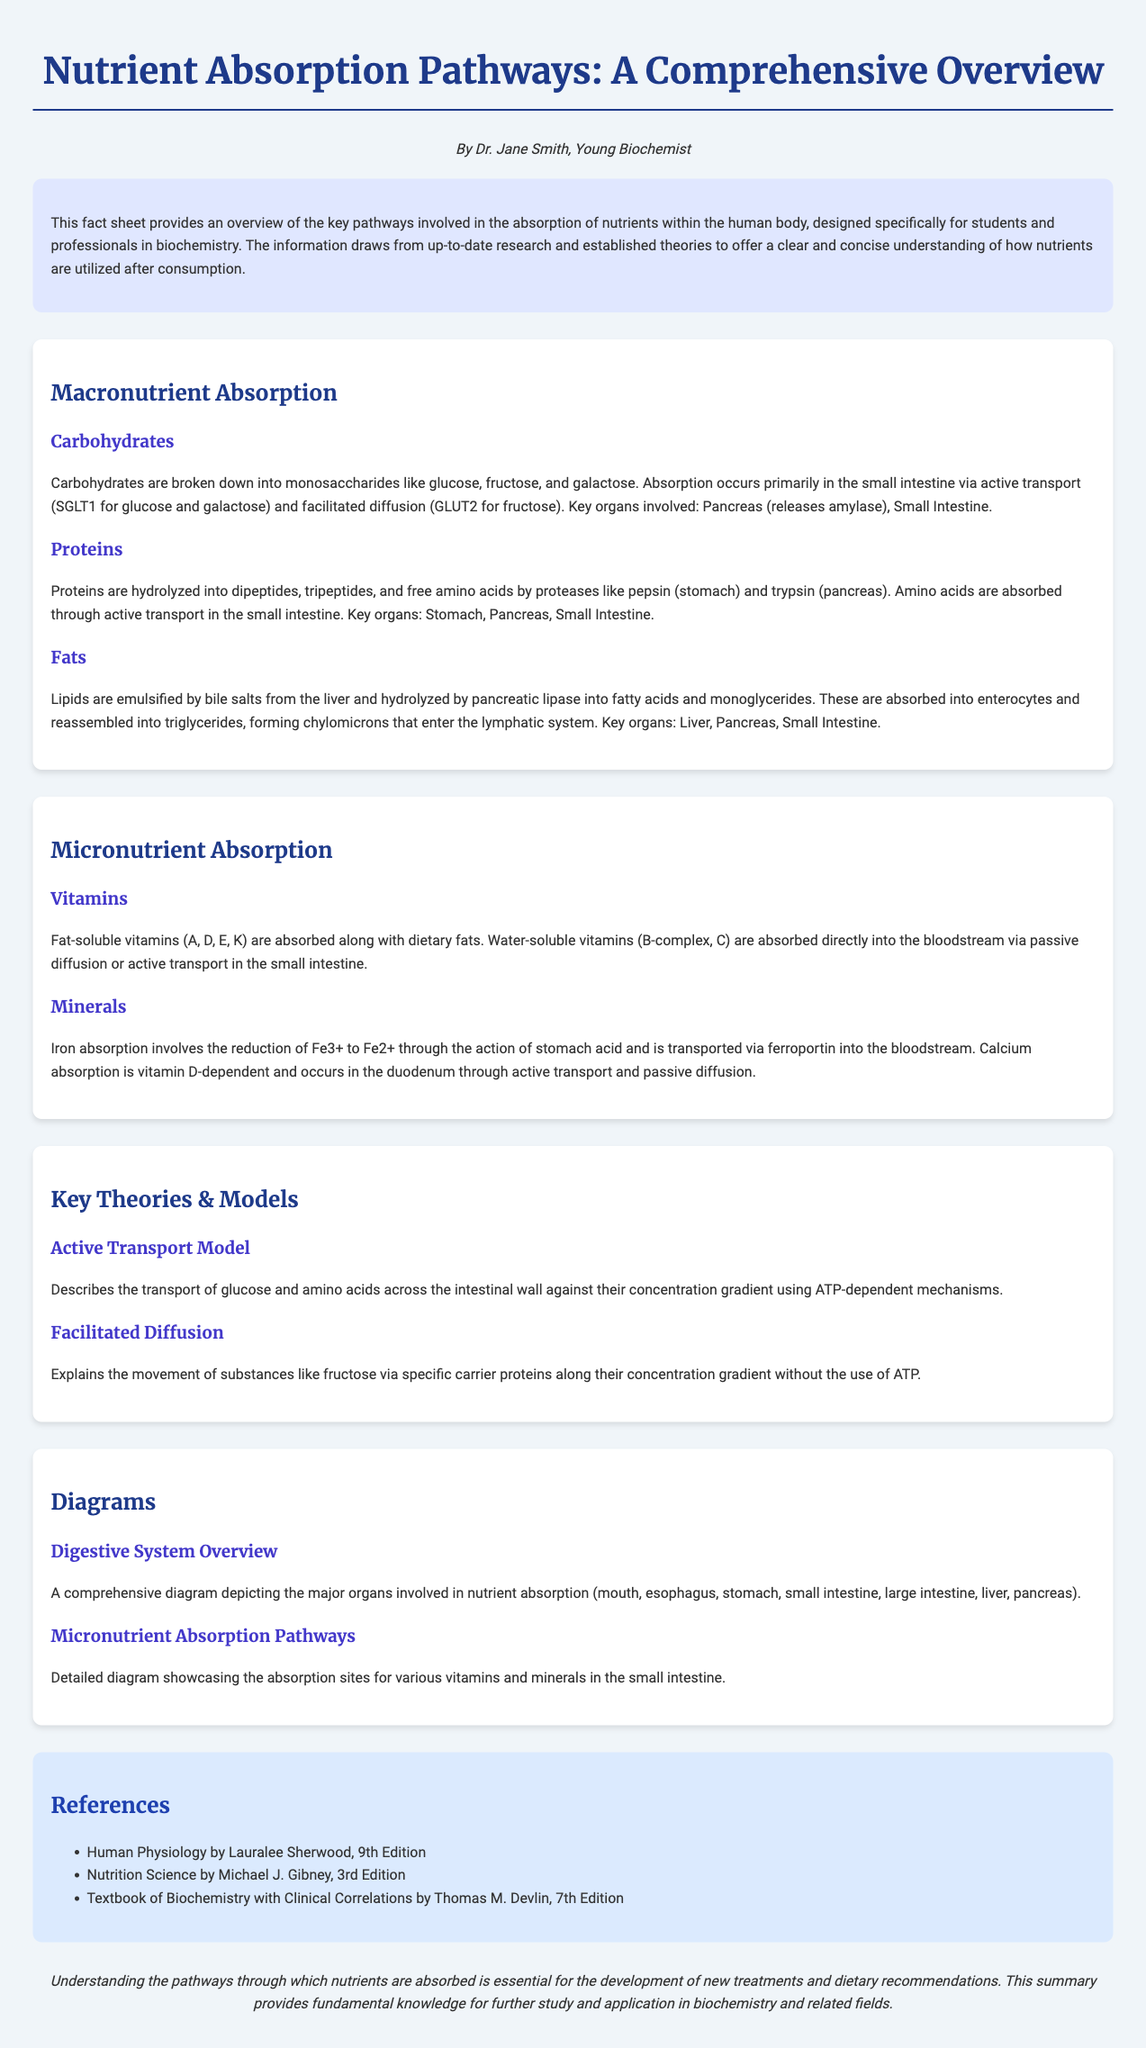What are the products of carbohydrate digestion? Carbohydrates are broken down into monosaccharides like glucose, fructose, and galactose.
Answer: monosaccharides What does SGLT1 transport? SGLT1 is responsible for the transport of glucose and galactose across the intestinal wall.
Answer: glucose and galactose Which vitamins are fat-soluble? The fat-soluble vitamins mentioned are A, D, E, and K.
Answer: A, D, E, K What is required for calcium absorption? Calcium absorption is dependent on vitamin D.
Answer: vitamin D What theory describes the transport of glucose against its concentration gradient? The Active Transport Model describes the transport.
Answer: Active Transport Model Which organ releases amylase for carbohydrate digestion? The pancreas releases amylase.
Answer: pancreas What diagram depicts the major organs involved in nutrient absorption? A comprehensive diagram depicts the major organs involved in nutrient absorption.
Answer: Digestive System Overview How are free amino acids absorbed? Free amino acids are absorbed through active transport in the small intestine.
Answer: active transport What are the key organs involved in fat digestion? Key organs involved in fat digestion are the liver, pancreas, and small intestine.
Answer: liver, pancreas, small intestine 